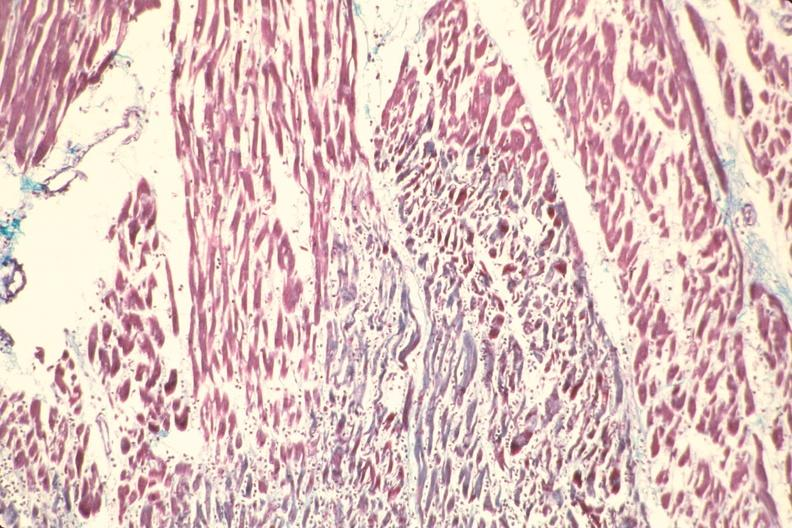what is present?
Answer the question using a single word or phrase. Cardiovascular 